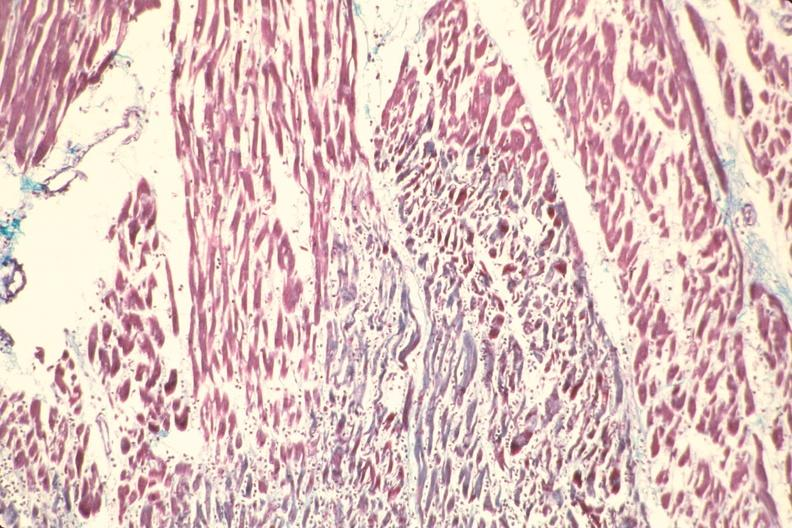what is present?
Answer the question using a single word or phrase. Cardiovascular 